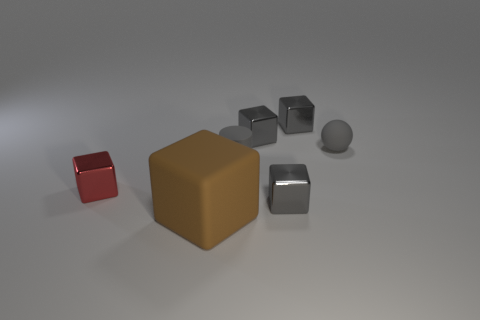Is there anything else that has the same size as the brown matte cube?
Make the answer very short. No. Are there any gray rubber cylinders of the same size as the gray rubber sphere?
Your answer should be compact. Yes. There is a red cube that is the same size as the cylinder; what material is it?
Keep it short and to the point. Metal. How many objects are matte objects on the right side of the large block or tiny things that are right of the red thing?
Provide a succinct answer. 5. Are there any tiny gray things of the same shape as the brown thing?
Offer a very short reply. Yes. What number of shiny objects are either red blocks or gray blocks?
Your answer should be very brief. 4. What is the shape of the large thing?
Ensure brevity in your answer.  Cube. What number of tiny gray balls are made of the same material as the gray cylinder?
Provide a short and direct response. 1. There is a small sphere that is the same material as the large cube; what color is it?
Your answer should be compact. Gray. There is a rubber thing that is to the right of the cylinder; is its size the same as the brown object?
Provide a short and direct response. No. 